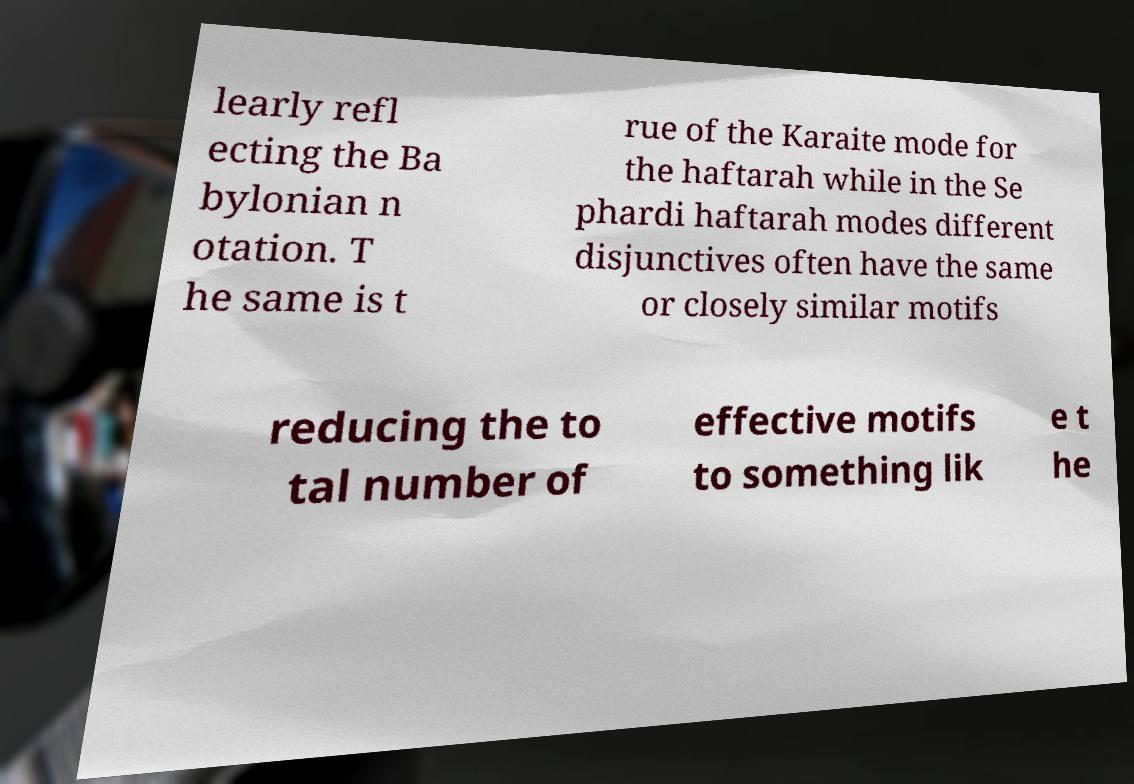What messages or text are displayed in this image? I need them in a readable, typed format. learly refl ecting the Ba bylonian n otation. T he same is t rue of the Karaite mode for the haftarah while in the Se phardi haftarah modes different disjunctives often have the same or closely similar motifs reducing the to tal number of effective motifs to something lik e t he 